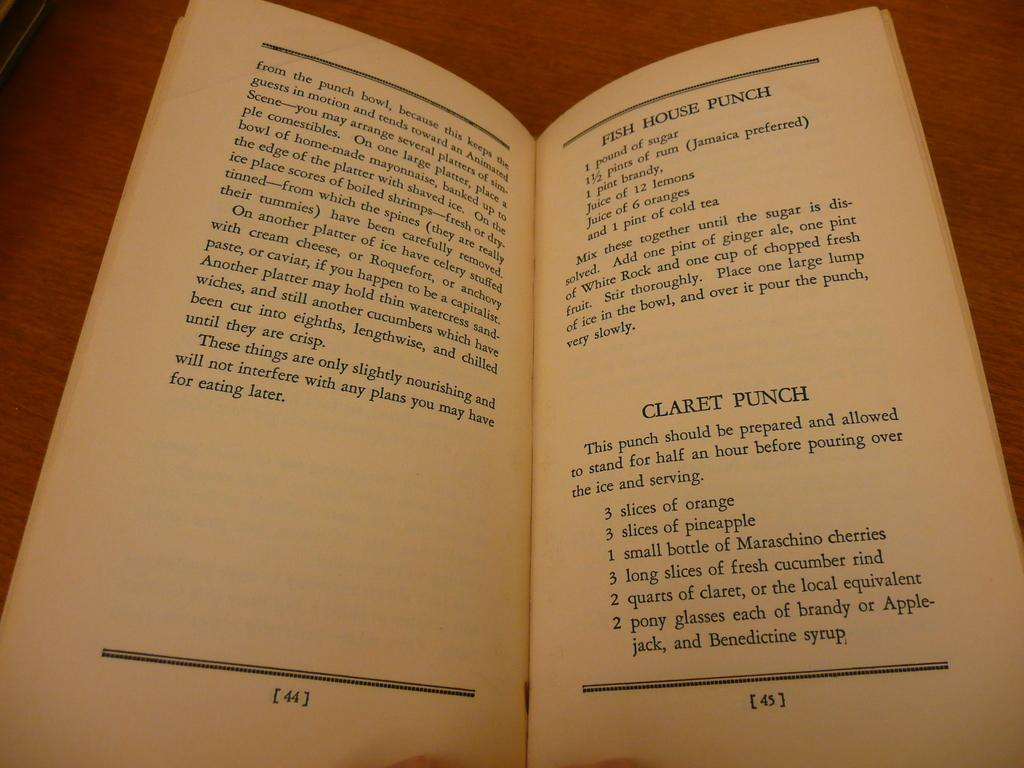<image>
Relay a brief, clear account of the picture shown. A page from a cocktail manual shows a recipe for Claret Punch. 